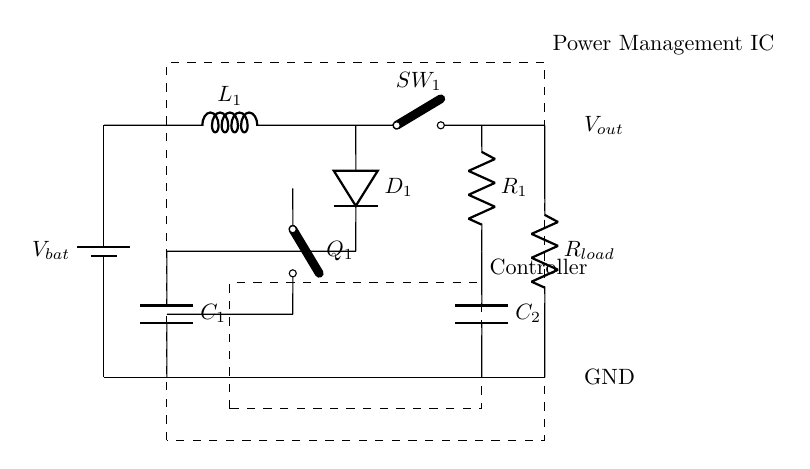What is the main power source for this circuit? The main power source in the circuit is the battery, indicated by the component labeled "V_bat." It provides the necessary voltage for operation.
Answer: Battery What type of component is labeled as "R_1"? "R_1" is a resistor, which is used in the circuit to limit current or divide voltage. Resistors are often utilized in power management circuits to stabilize voltage levels.
Answer: Resistor What is the role of the component "D_1"? "D_1" is a diode, which allows current to flow in one direction while blocking it in the opposite direction. In power management, it prevents backflow and protects components.
Answer: Diode Which component is responsible for voltage regulation? The component that regulates voltage is the LDO Regulator, represented by the label "R_1" in conjunction with capacitor "C_2." The LDO maintains a steady output voltage from varying input voltages.
Answer: LDO Regulator How many switches are present in the circuit? The circuit contains two switches, "Q_1" and "SW_1," that control the flow of current and manage the connection of the load.
Answer: Two What happens when "SW_1" is closed? When "SW_1" is closed, it connects the load to the output voltage, allowing current to flow through "R_load" and powering the connected device. This enables the device to function properly during operation.
Answer: Current flows to load What voltage does "V_out" represent? "V_out" represents the output voltage available for the load after passing through the power management system. This voltage is optimized to enhance battery life and circuit efficiency in mobile devices.
Answer: Output voltage 